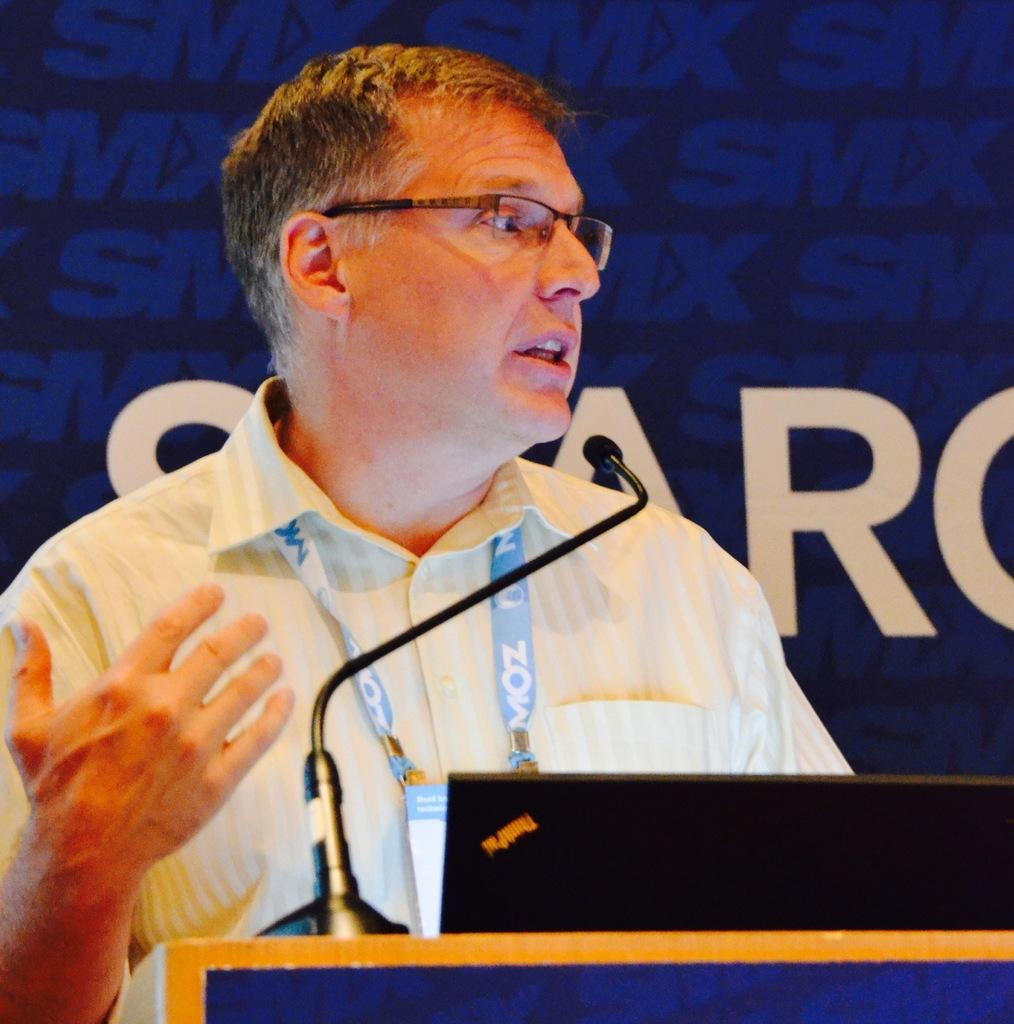What is the main subject of the image? The main subject of the image is a man. Can you describe the man's appearance? The man is wearing spectacles. Is there any additional information about the man? A: Yes, the man has a tag around his neck. What is the man standing in front of? The man is standing in front of a mic on a podium. What time does the clock on the wall show in the image? There is no clock present in the image. How many trains can be seen passing by in the image? There are no trains visible in the image. What type of cloud formation can be seen in the image? There is no cloud formation present in the image. 